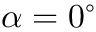<formula> <loc_0><loc_0><loc_500><loc_500>\alpha = 0 ^ { \circ }</formula> 